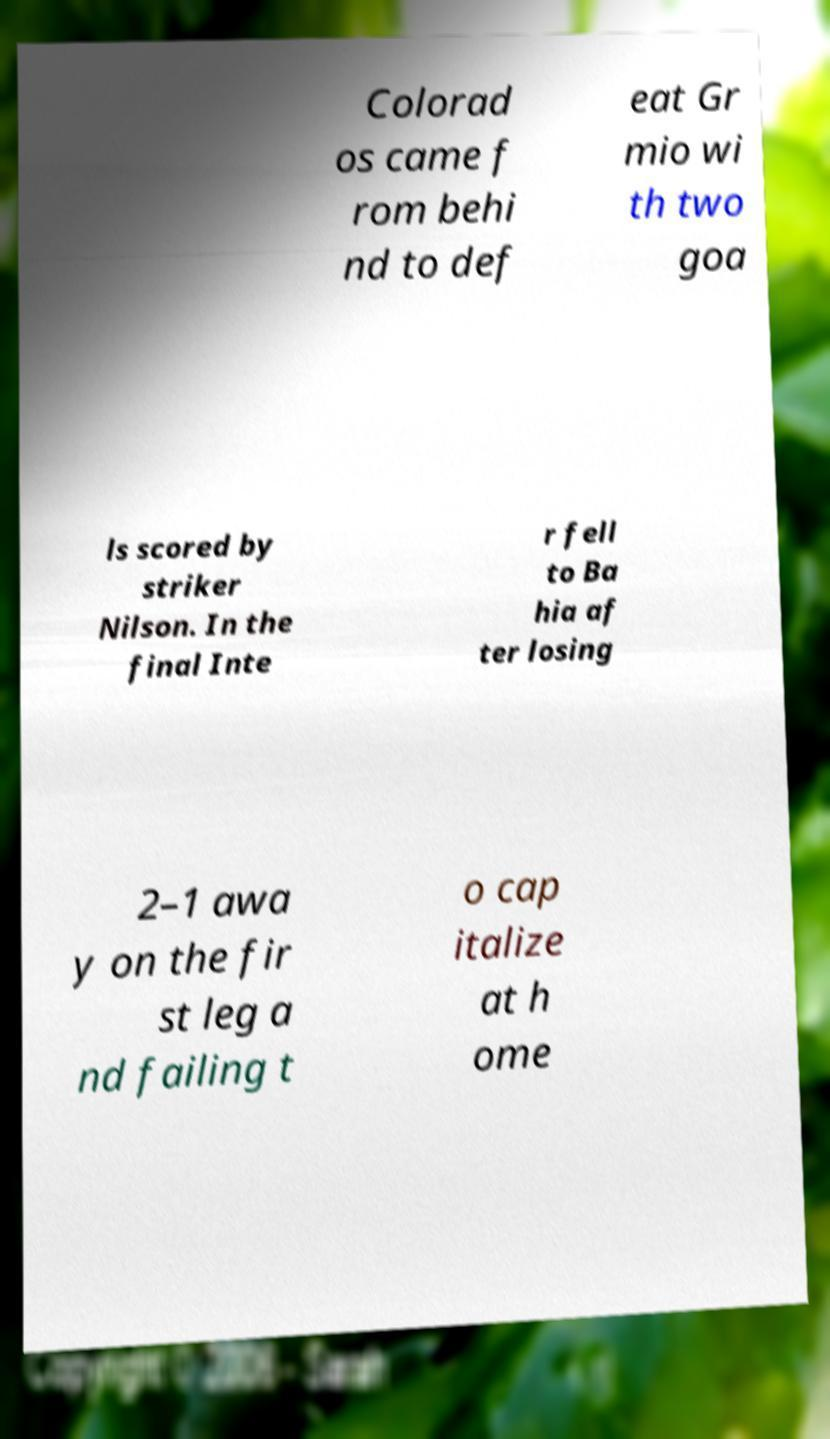Can you accurately transcribe the text from the provided image for me? Colorad os came f rom behi nd to def eat Gr mio wi th two goa ls scored by striker Nilson. In the final Inte r fell to Ba hia af ter losing 2–1 awa y on the fir st leg a nd failing t o cap italize at h ome 